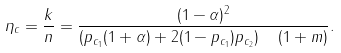Convert formula to latex. <formula><loc_0><loc_0><loc_500><loc_500>\eta _ { c } & = \frac { k } { n } = \frac { ( 1 - \alpha ) ^ { 2 } } { \left ( p _ { c _ { 1 } } ( 1 + \alpha ) + 2 ( 1 - p _ { c _ { 1 } } ) p _ { c _ { 2 } } \right ) \quad ( 1 + m ) } .</formula> 